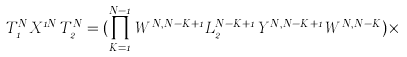Convert formula to latex. <formula><loc_0><loc_0><loc_500><loc_500>T _ { 1 } ^ { N } X ^ { 1 N } T _ { 2 } ^ { N } = ( \prod _ { K = 1 } ^ { N - 1 } W ^ { N , N - K + 1 } L _ { 2 } ^ { N - K + 1 } Y ^ { N , N - K + 1 } W ^ { N , N - K } ) \times</formula> 